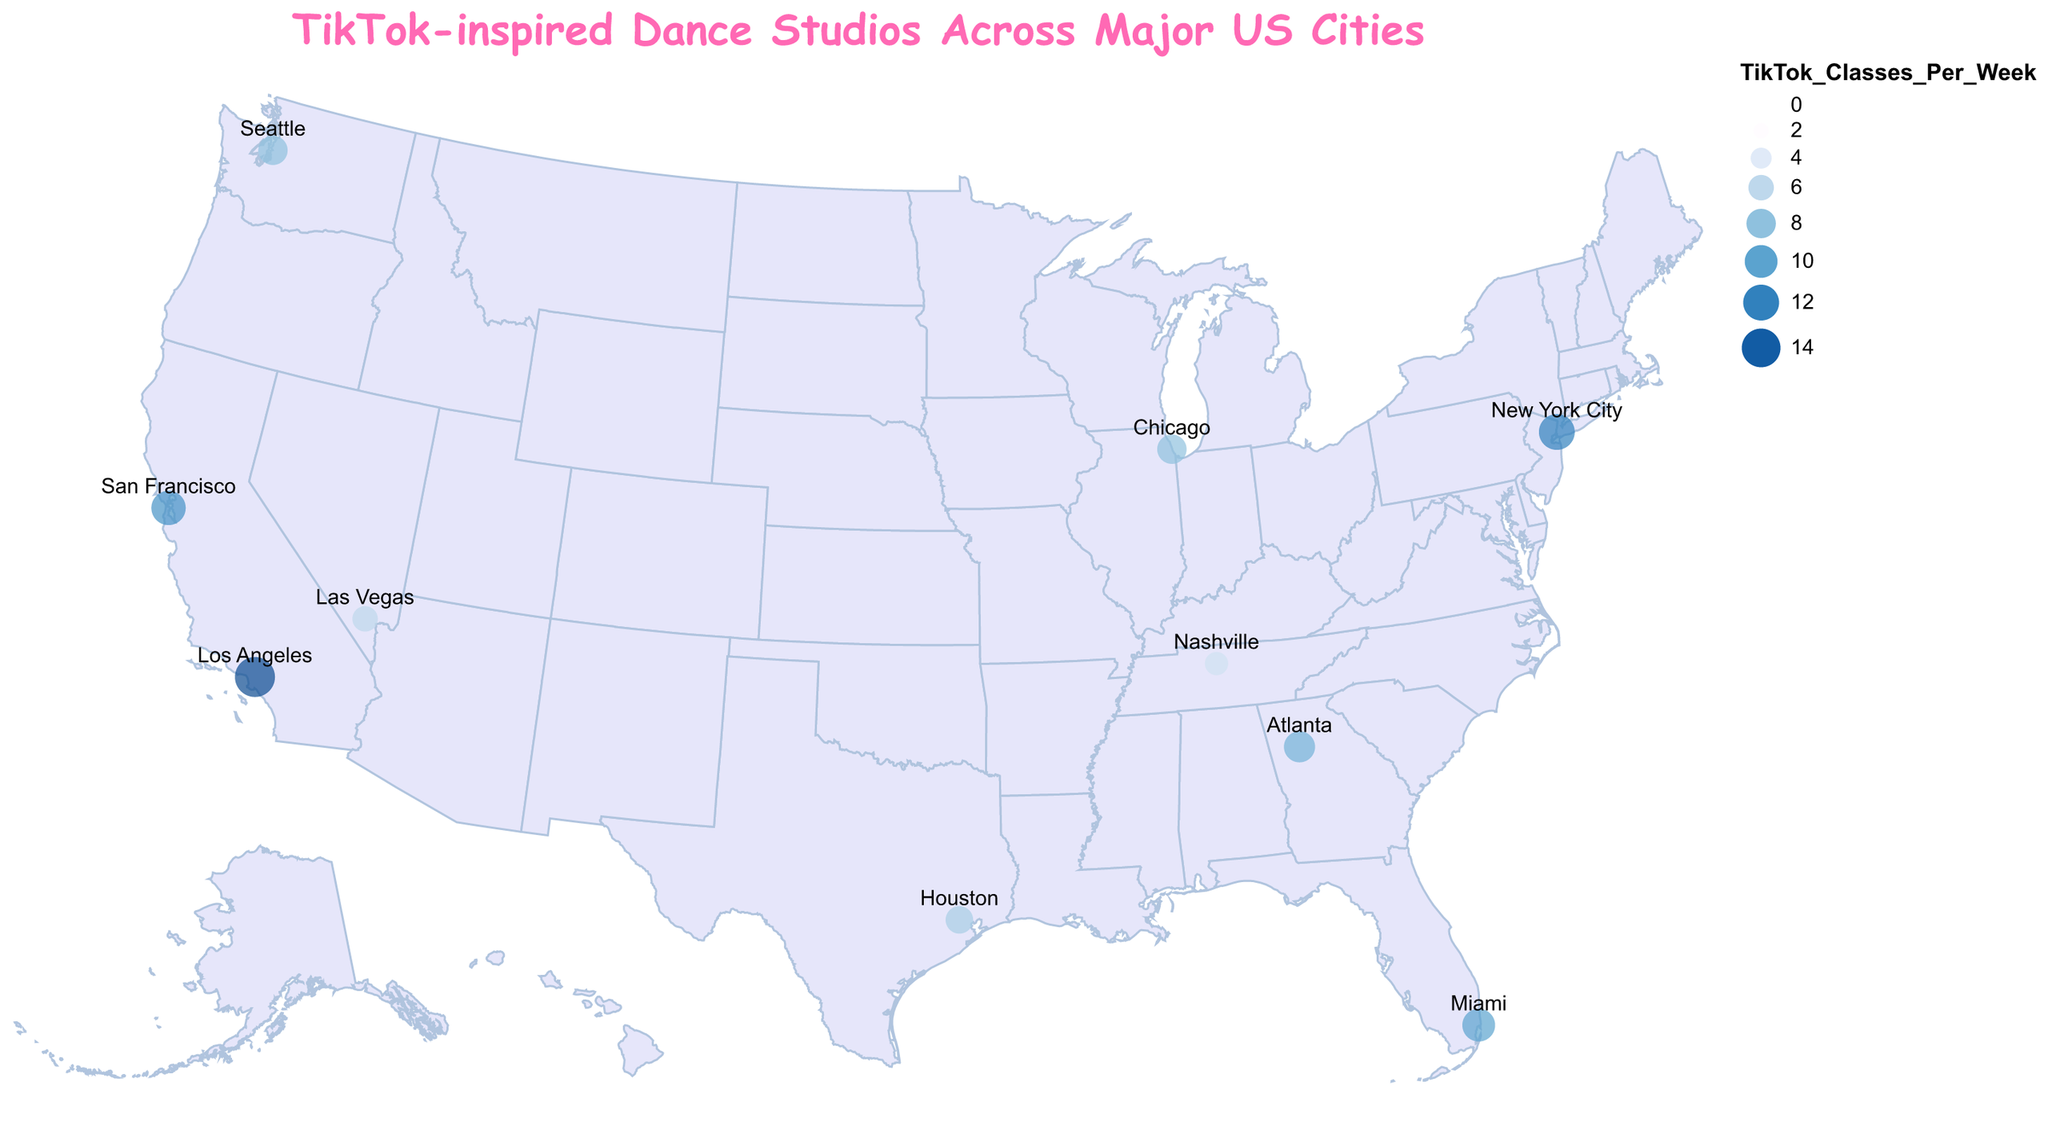Which city has the highest number of TikTok-inspired dance classes per week? The size of the circle and the color in Los Angeles indicate it has the highest value. Checking the tooltip confirms 15 classes per week.
Answer: Los Angeles What color represents cities with fewer TikTok classes per week? Cities with fewer classes are represented by darker colors, according to the color scale using the viridis scheme.
Answer: Darker colors Which city has the least TikTok-inspired dance classes per week? The smallest circle and darkest color can be seen in Nashville. The tooltip confirms it has 5 classes per week.
Answer: Nashville How many cities have more than 10 TikTok classes per week? By observing the size and colors of the circles, Los Angeles, New York City, Miami, and San Francisco have more than 10 classes.
Answer: 4 What is the average number of TikTok-inspired classes per week among the listed cities? Sum of classes (15 + 12 + 10 + 8 + 9 + 7 + 11 + 6 + 5 + 8) = 91. Number of cities = 10. The average is 91/10.
Answer: 9.1 Which popular instructor is associated with the studio in Atlanta? The tooltip for Atlanta shows Sync'd Up Studios with JoJo Siwa as the popular instructor.
Answer: JoJo Siwa What is the total number of TikTok-inspired dance classes per week offered in cities located west of the Mississippi River? These cities are Los Angeles, San Francisco, Las Vegas, Houston, Seattle. Sum of classes = 15 + 11 + 6 + 7 + 8 = 47.
Answer: 47 How do the number of TikTok classes in New York City compare to those in Chicago? New York City has a larger circle and lighter color than Chicago. According to the tooltips, New York City has 12 classes and Chicago has 8.
Answer: New York City has more In which city do Addison Rae's classes take place? The tooltip for Los Angeles indicates Addison Rae is the popular instructor at Viral Vibes Dance Studio.
Answer: Los Angeles Which city has more TikTok-inspired dance classes per week: Miami or Seattle? By examining the size and color, Miami’s circle is larger and lighter than Seattle’s. The tooltips confirm Miami has 10 classes while Seattle has 8.
Answer: Miami 